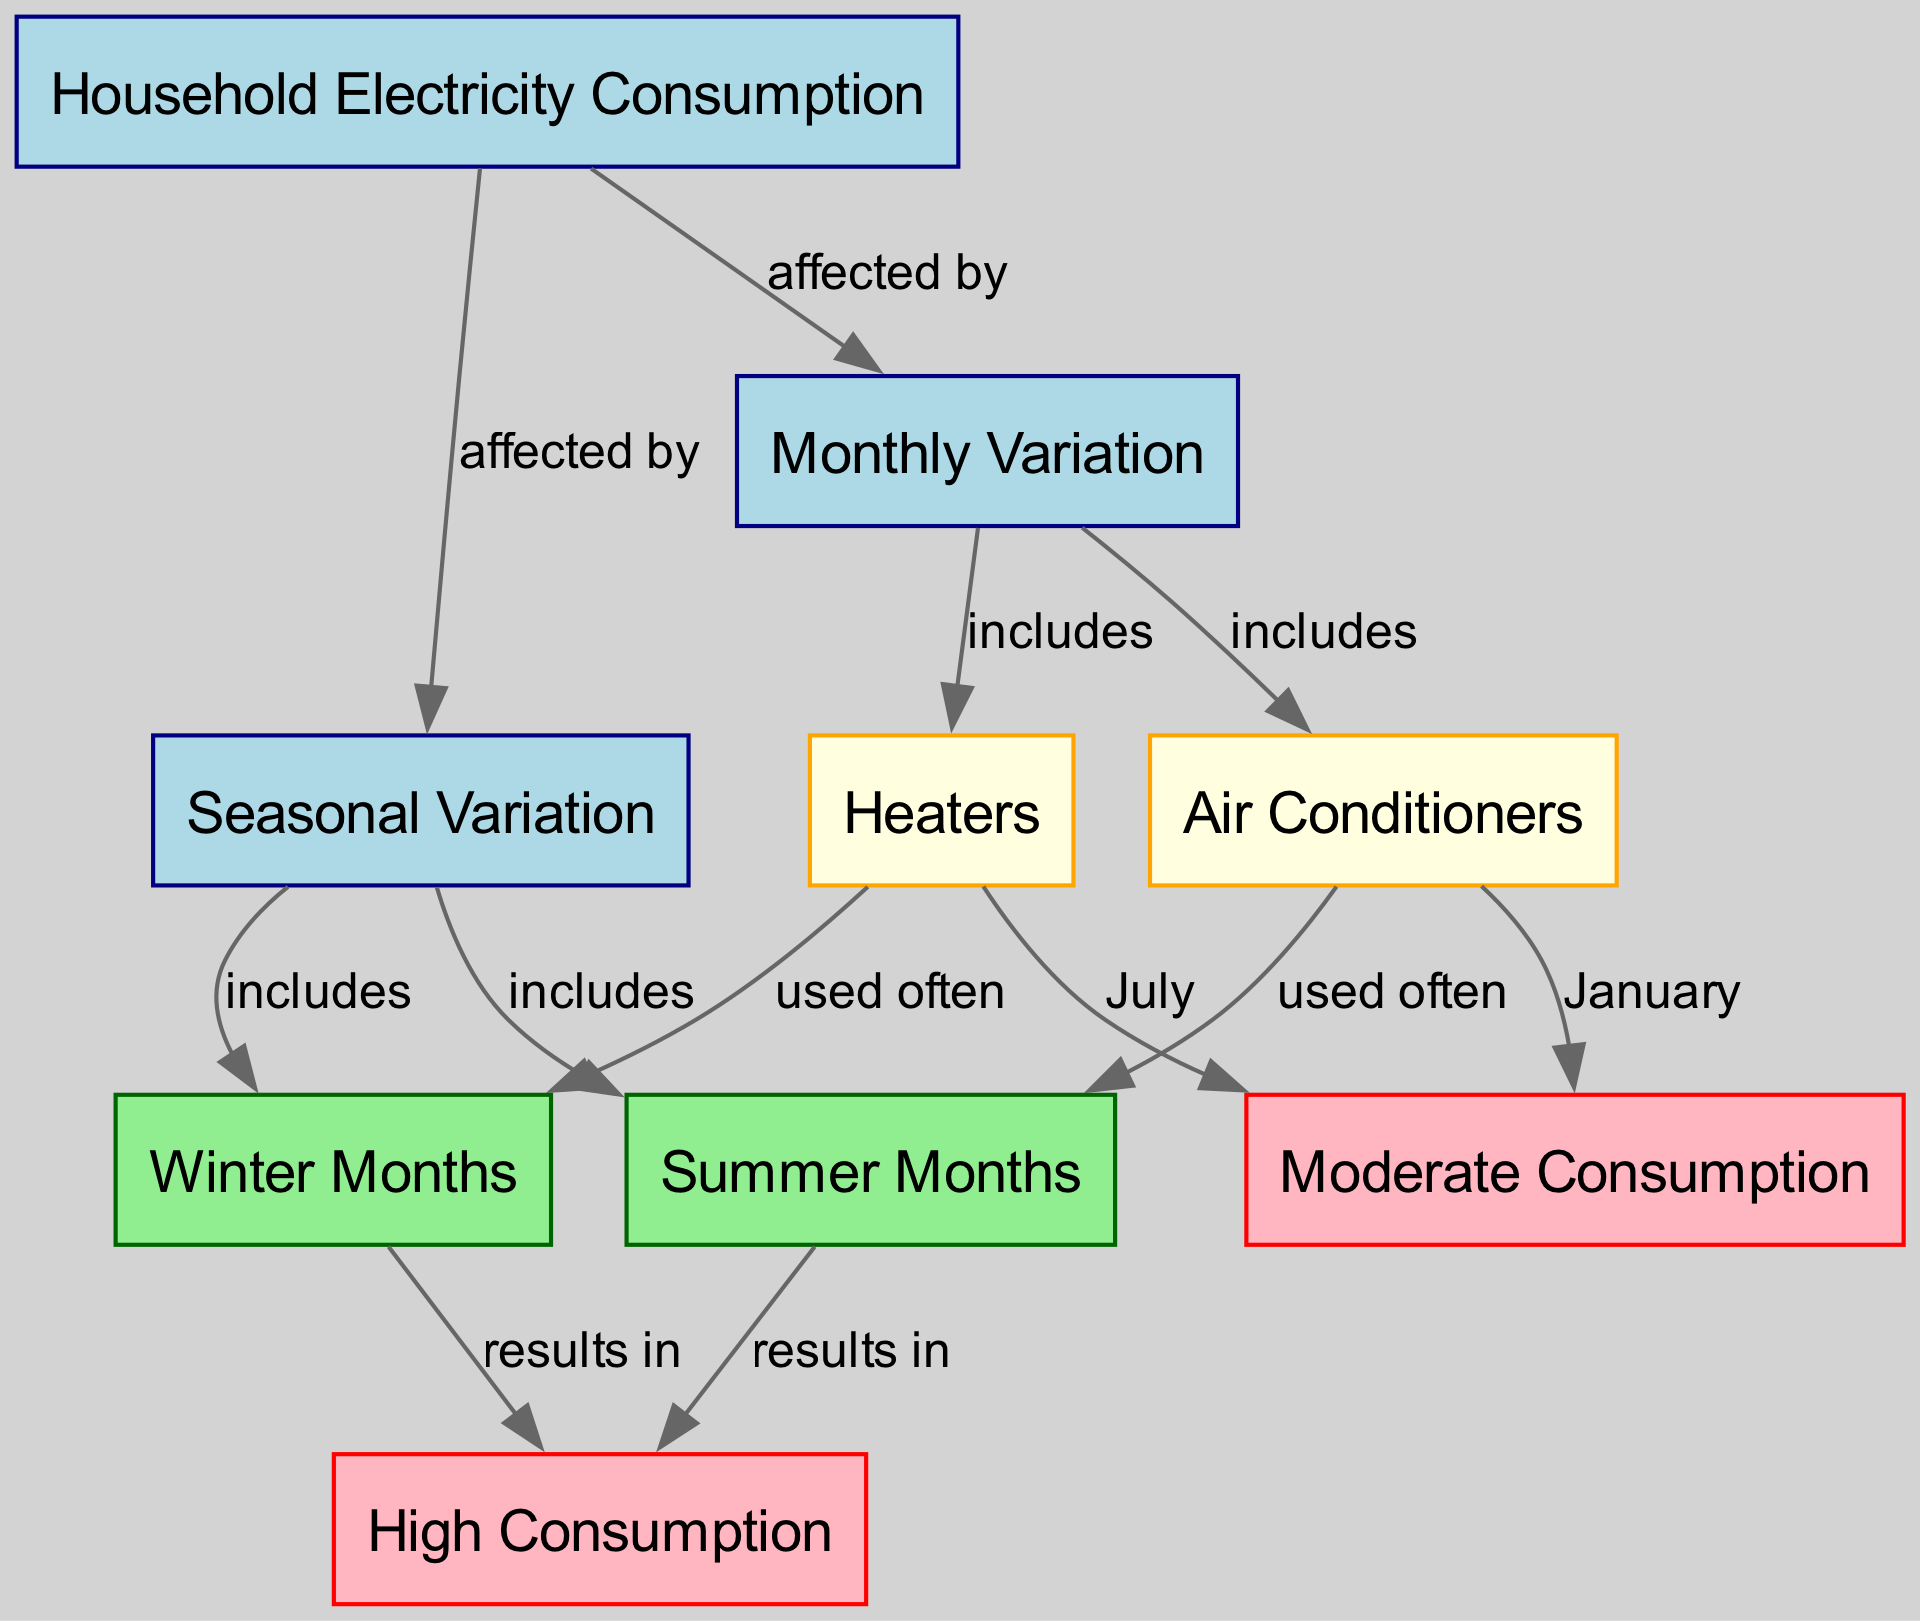What are the two main factors affecting household electricity consumption? The diagram shows that household electricity consumption is affected by monthly variation and seasonal variation, indicated by the edges leading from the "Household Electricity Consumption" node to "Monthly Variation" and "Seasonal Variation" nodes.
Answer: Monthly variation and seasonal variation Which appliances are included in monthly variation? The diagram indicates that the appliances included in the monthly variation are air conditioners and heaters, as seen from the edges leading from the "Monthly Variation" node to those appliances.
Answer: Air conditioners and heaters During which season is "High Consumption" most likely to occur? According to the diagram, high consumption results from both summer months and winter months, as indicated by the connections from these seasonal nodes to the "High Consumption" node.
Answer: Summer months and winter months What type of consumption is air conditioners associated with in January? The diagram shows that air conditioners are associated with moderate consumption in January, indicated by the edge linking air conditioners to the moderate consumption node.
Answer: Moderate consumption What is the common result of using both air conditioners in summer and heaters in winter? The diagram indicates that both air conditioners used in summer and heaters used in winter result in high consumption, as shown by the edges leading from both devices to the "High Consumption" node.
Answer: High consumption 